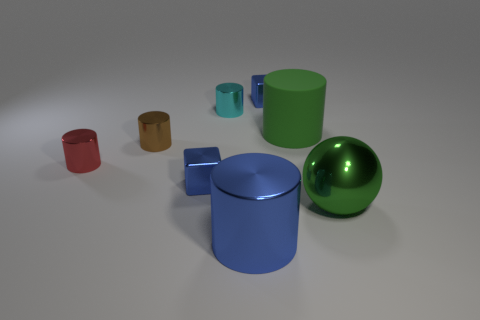Subtract all rubber cylinders. How many cylinders are left? 4 Add 1 small purple balls. How many objects exist? 9 Subtract all green cylinders. How many cylinders are left? 4 Subtract 1 balls. How many balls are left? 0 Subtract all balls. How many objects are left? 7 Subtract all cyan cylinders. Subtract all gray spheres. How many cylinders are left? 4 Subtract all brown cylinders. How many red spheres are left? 0 Subtract all blue shiny cylinders. Subtract all metal balls. How many objects are left? 6 Add 5 red cylinders. How many red cylinders are left? 6 Add 2 green metallic balls. How many green metallic balls exist? 3 